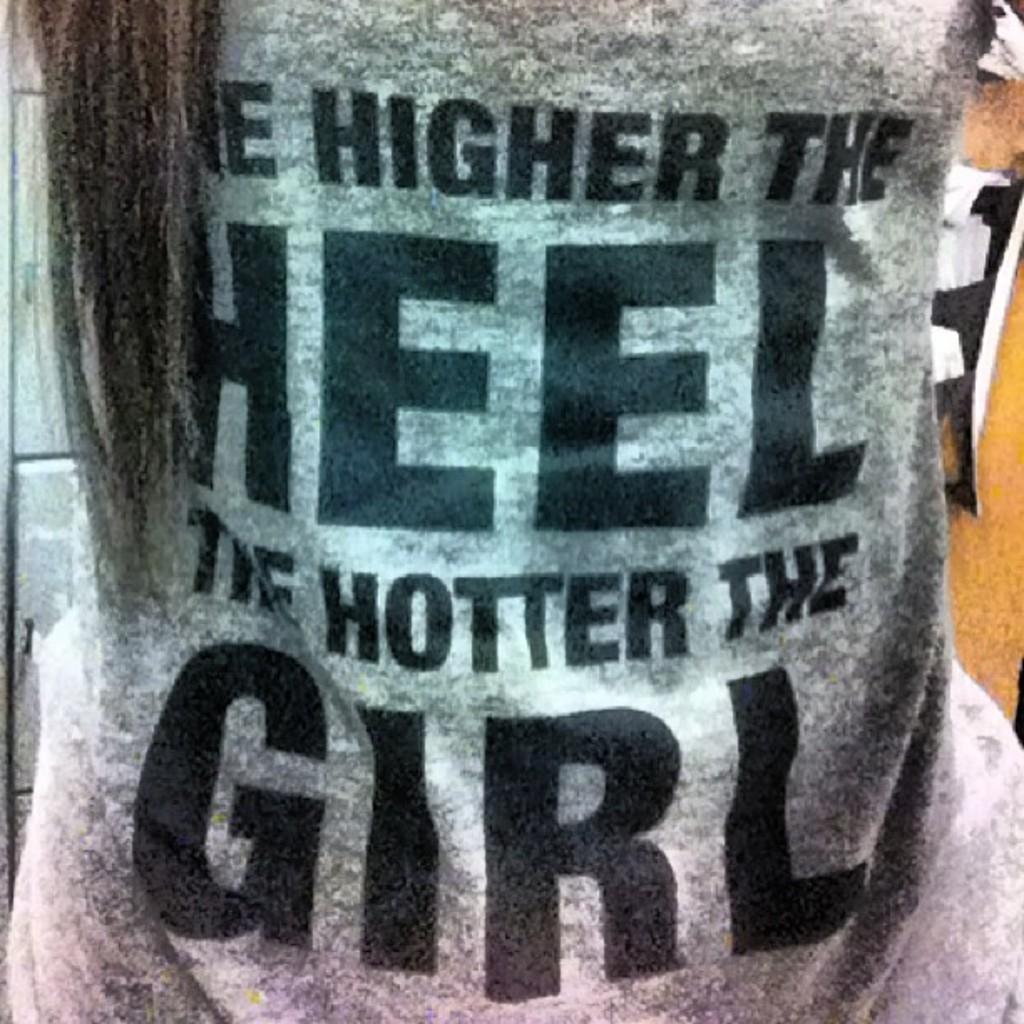Please provide a concise description of this image. In this image we can see a t-shirt with some text on it. 